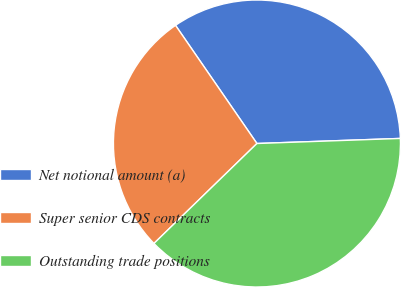<chart> <loc_0><loc_0><loc_500><loc_500><pie_chart><fcel>Net notional amount (a)<fcel>Super senior CDS contracts<fcel>Outstanding trade positions<nl><fcel>34.04%<fcel>27.66%<fcel>38.3%<nl></chart> 